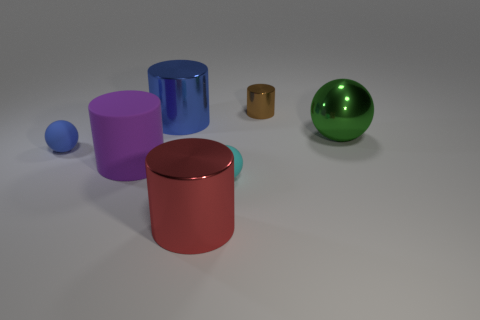Comparing the sizes, can you tell which is the largest object and which is the smallest? The largest object in the image is a red cylinder, while the smallest one appears to be a small blue sphere. 